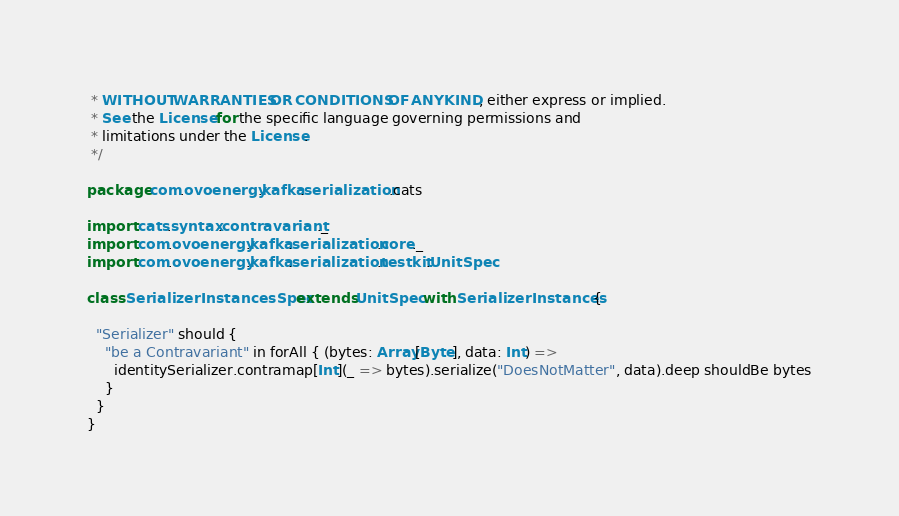<code> <loc_0><loc_0><loc_500><loc_500><_Scala_> * WITHOUT WARRANTIES OR CONDITIONS OF ANY KIND, either express or implied.
 * See the License for the specific language governing permissions and
 * limitations under the License.
 */

package com.ovoenergy.kafka.serialization.cats

import cats.syntax.contravariant._
import com.ovoenergy.kafka.serialization.core._
import com.ovoenergy.kafka.serialization.testkit.UnitSpec

class SerializerInstancesSpec extends UnitSpec with SerializerInstances {

  "Serializer" should {
    "be a Contravariant" in forAll { (bytes: Array[Byte], data: Int) =>
      identitySerializer.contramap[Int](_ => bytes).serialize("DoesNotMatter", data).deep shouldBe bytes
    }
  }
}
</code> 